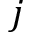Convert formula to latex. <formula><loc_0><loc_0><loc_500><loc_500>j</formula> 